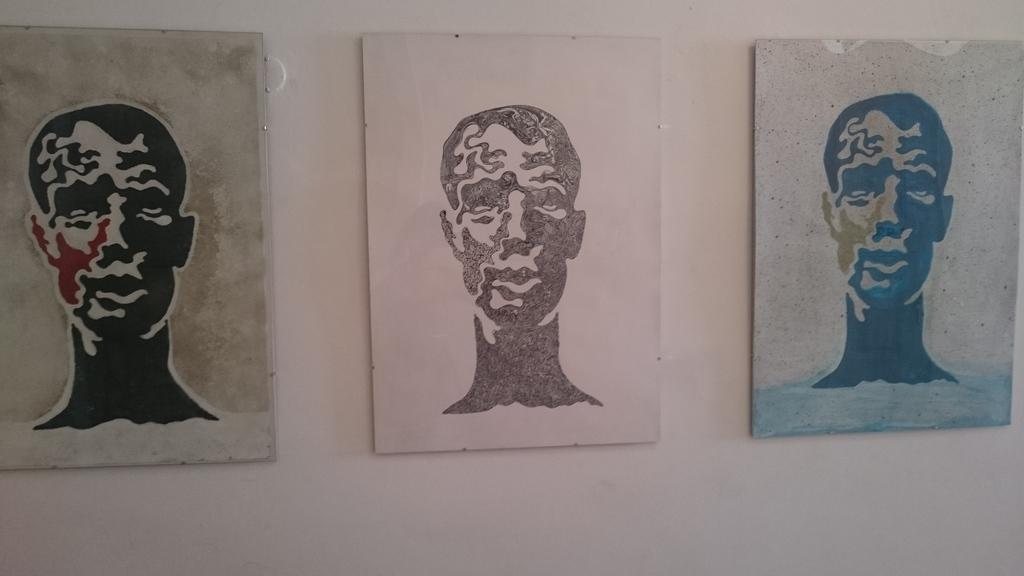How many photo frames are on the wall in the image? There are three photo frames on the wall in the image. What type of artwork is displayed in the photo frames? The photo frames contain paintings of human heads. What type of flame can be seen in the image? There is no flame present in the image. How does the son contribute to the artwork in the image? There is no son present in the image, and therefore no contribution can be observed. 